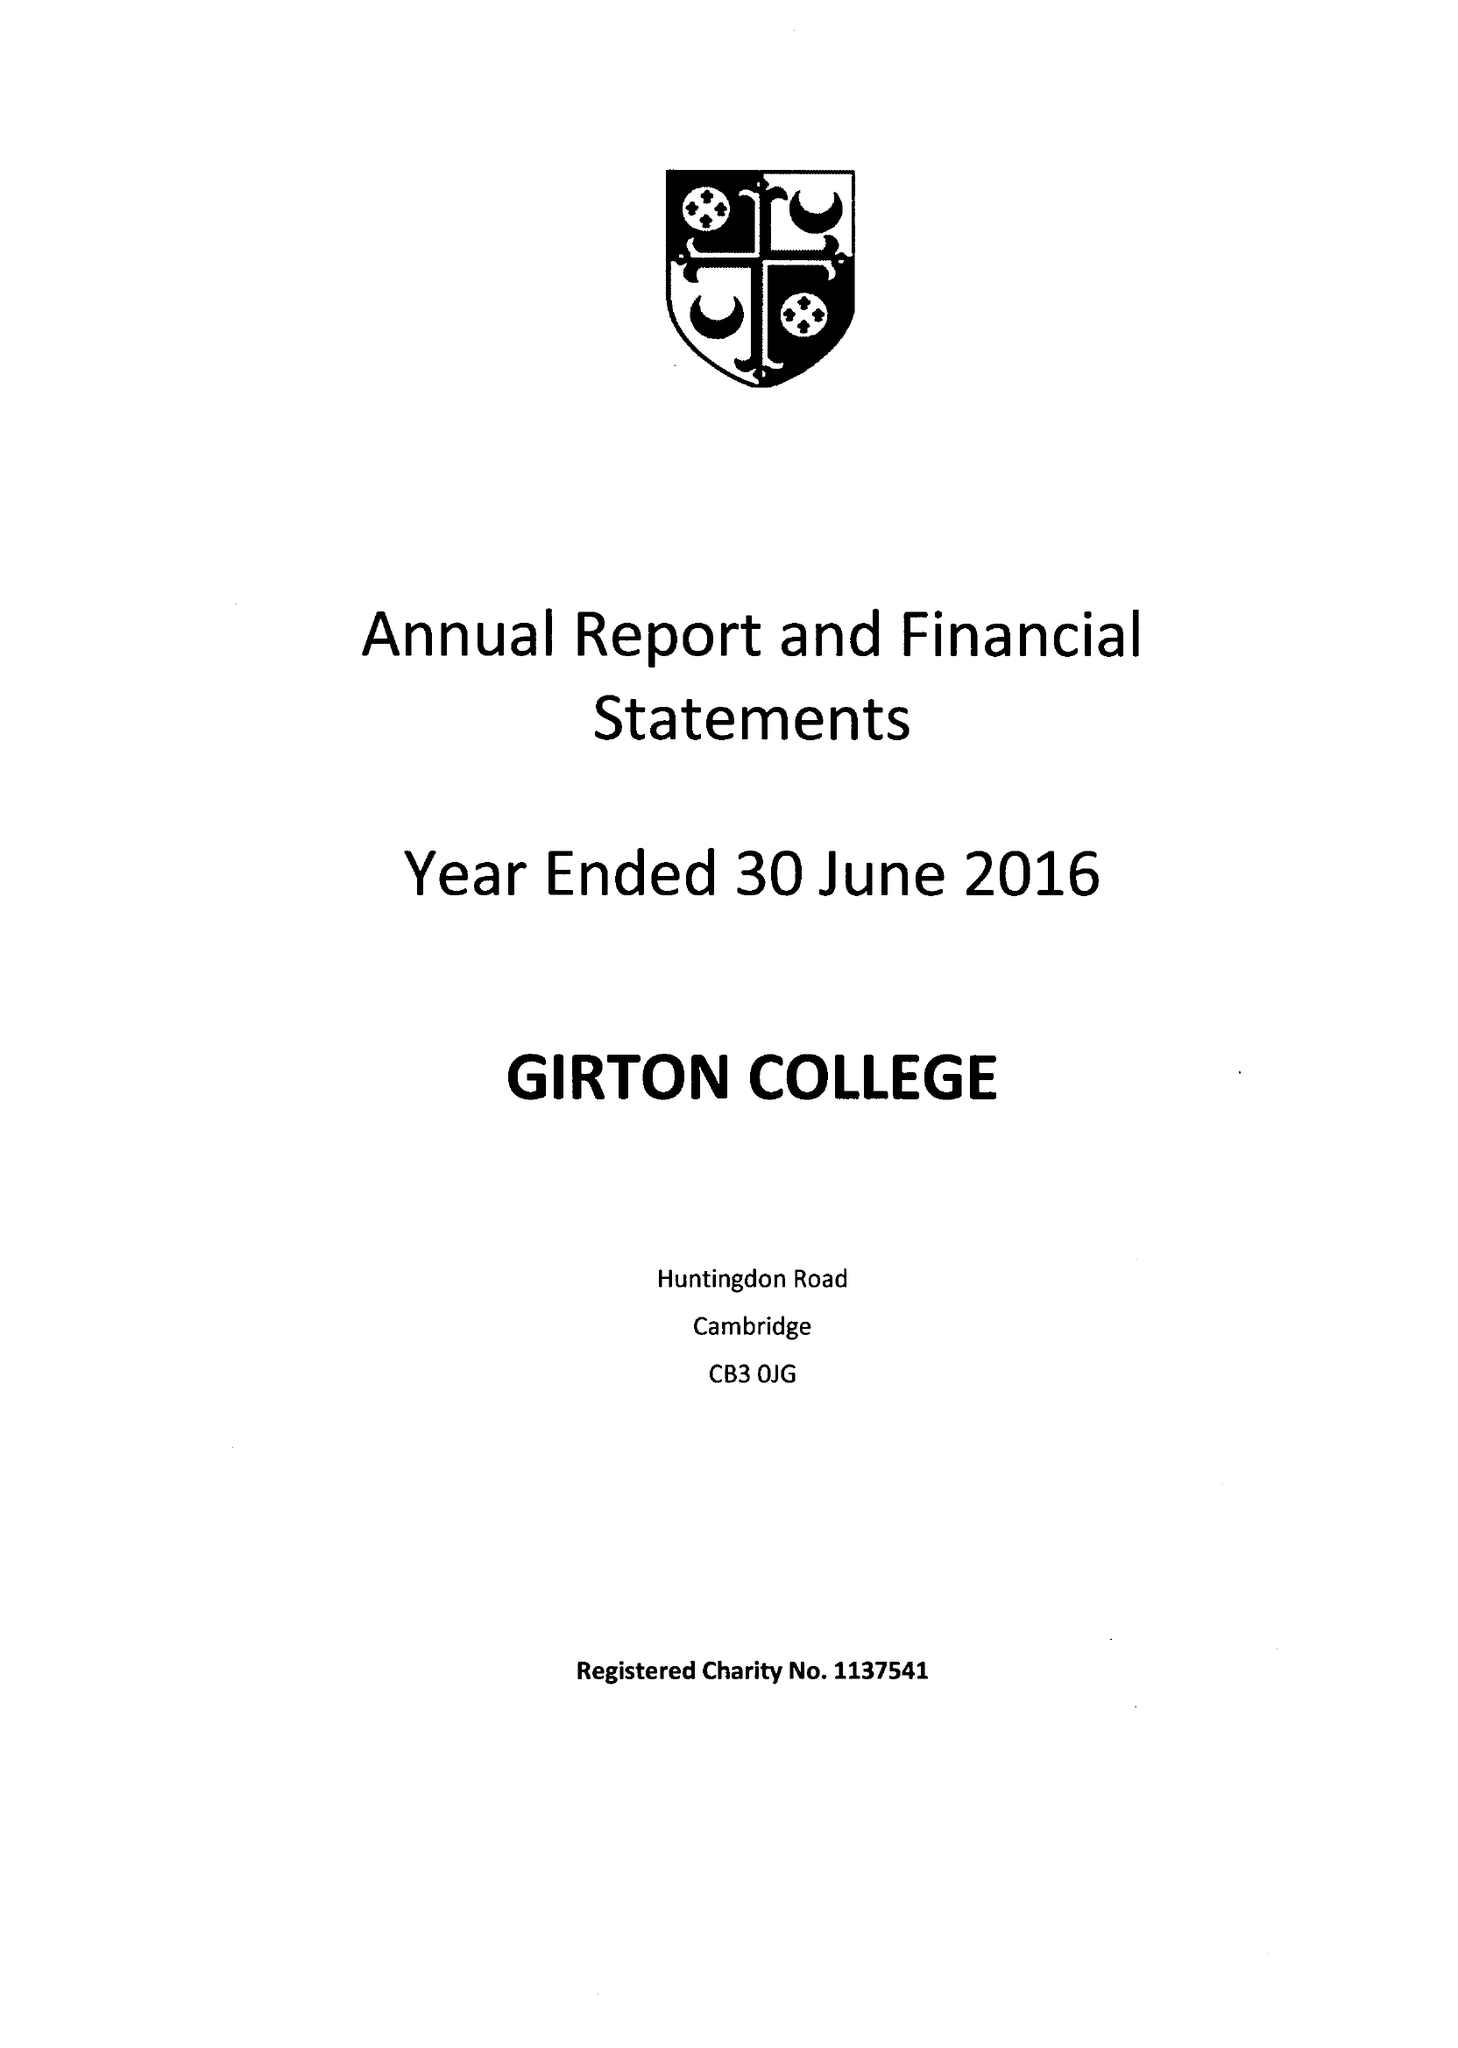What is the value for the income_annually_in_british_pounds?
Answer the question using a single word or phrase. 10104000.00 